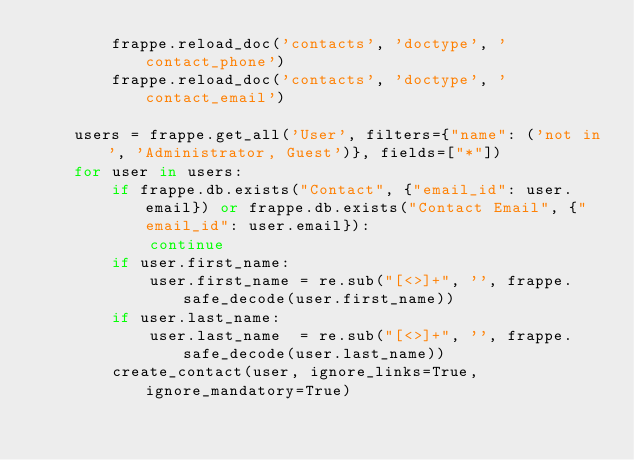Convert code to text. <code><loc_0><loc_0><loc_500><loc_500><_Python_>		frappe.reload_doc('contacts', 'doctype', 'contact_phone')
		frappe.reload_doc('contacts', 'doctype', 'contact_email')

	users = frappe.get_all('User', filters={"name": ('not in', 'Administrator, Guest')}, fields=["*"])
	for user in users:
		if frappe.db.exists("Contact", {"email_id": user.email}) or frappe.db.exists("Contact Email", {"email_id": user.email}):
			continue
		if user.first_name:
			user.first_name = re.sub("[<>]+", '', frappe.safe_decode(user.first_name))
		if user.last_name:
			user.last_name  = re.sub("[<>]+", '', frappe.safe_decode(user.last_name))
		create_contact(user, ignore_links=True, ignore_mandatory=True)
</code> 